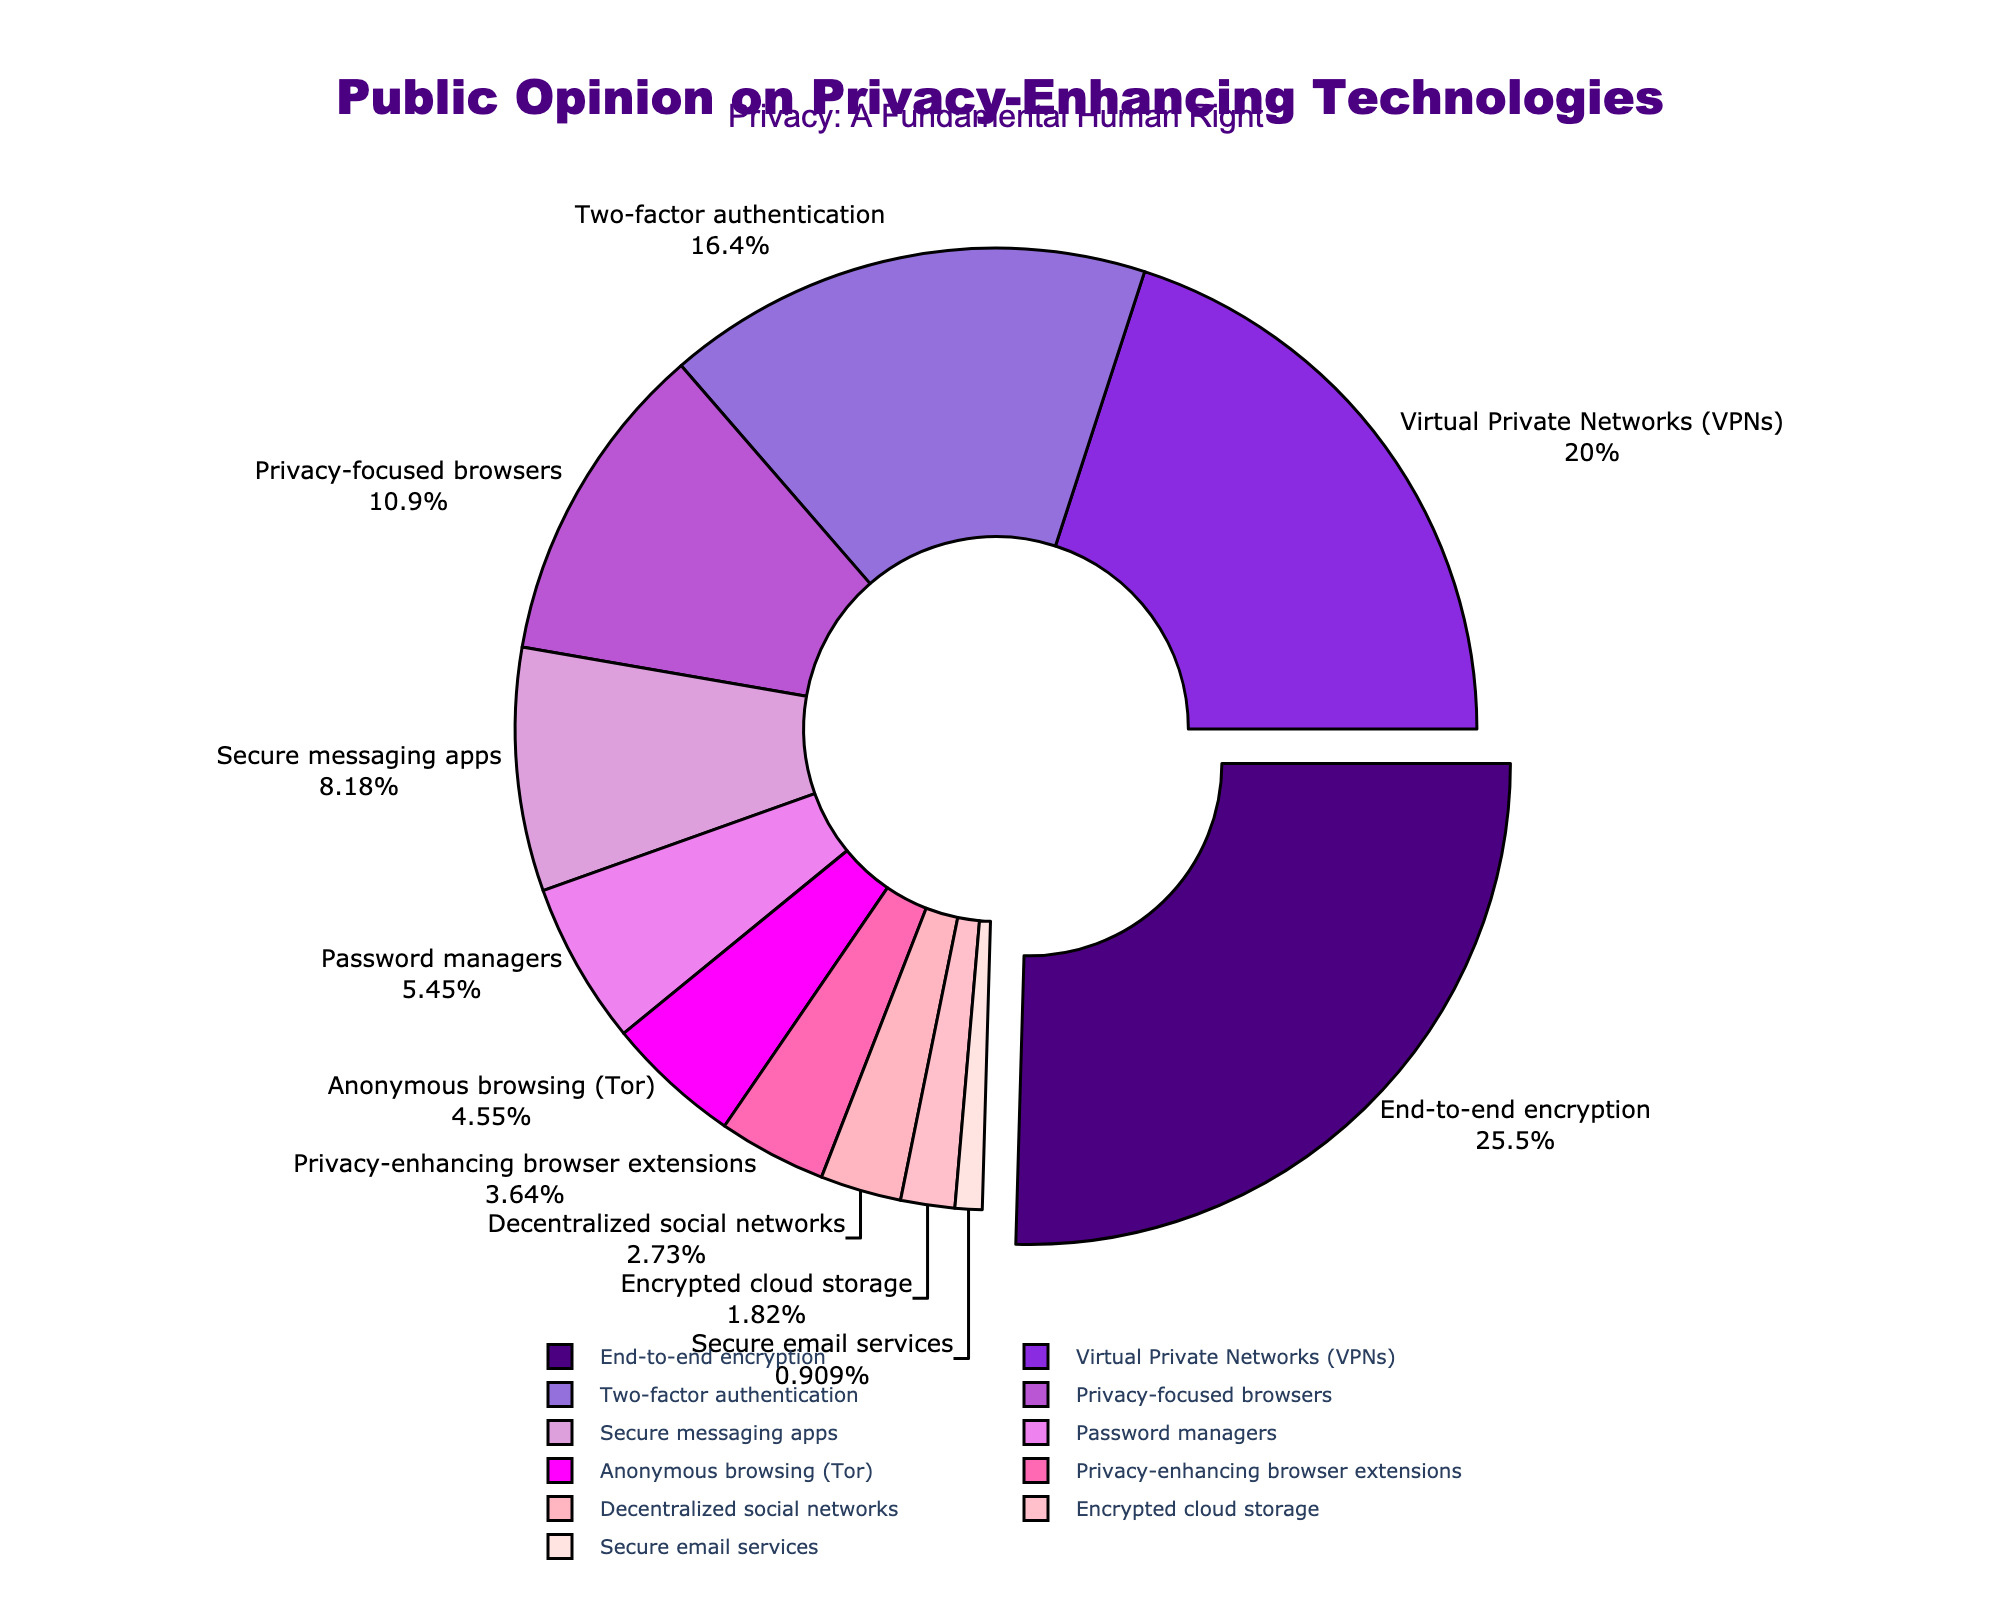what percentage of people prefer Privacy-focused browsers over Secure messaging apps? The figure shows that 12% of people prefer Privacy-focused browsers while 9% prefer Secure messaging apps. To calculate the percentage difference, subtract 9% from 12%, which results in 3%.
Answer: 3% Which privacy-enhancing technology is preferred by the largest share of people? Observing the pie chart, "End-to-end encryption" segment is the largest, indicating it's preferred by 28% of people, making it the most preferred technology.
Answer: End-to-end encryption What is the combined percentage of people who prefer technologies for password protection, i.e., Two-factor authentication and Password managers? To find the combined percentage, add the percentage of people who prefer Two-factor authentication (18%) and Password managers (6%). The sum is 18% + 6% = 24%.
Answer: 24% Are there more people who prefer VPNs or End-to-end encryption? According to the pie chart, 22% of people prefer VPNs while 28% prefer End-to-end encryption. Comparing these values, more people prefer End-to-end encryption.
Answer: End-to-end encryption What is the percentage difference between the least and the most preferred privacy-enhancing technologies? The least preferred technology is Secure email services (1%) and the most preferred is End-to-end encryption (28%). The percentage difference between them is 28% - 1% = 27%.
Answer: 27% What fraction of participants prefer technologies related to secure communication (considering Secure messaging apps, Two-factor authentication, and Secure email services)? Adding the percentages of Secure messaging apps (9%), Two-factor authentication (18%), and Secure email services (1%), we get 9% + 18% + 1% = 28%. This means 28% of participants prefer secure communication technologies.
Answer: 28% What is the cumulative percentage of people who favor technologies rated below Password managers? The technologies rated below Password managers (6%) include Anonymous browsing (Tor) (5%), Privacy-enhancing browser extensions (4%), Decentralized social networks (3%), Encrypted cloud storage (2%), and Secure email services (1%). Adding these, 5% + 4% + 3% + 2% + 1% = 15%.
Answer: 15% Which segment, indicated by a color closest to pink, corresponds to which technology? A segment colored closest to pink in the pie chart corresponds to Privacy-enhancing browser extensions (4%).
Answer: Privacy-enhancing browser extensions Considering the technologies listed, what is the average percentage preference? To compute the average preference, sum up all the given percentages and divide by the total number of technologies. (28% + 22% + 18% + 12% + 9% + 6% + 5% + 4% + 3% + 2% + 1% = 110%). The number of technologies is 11. Therefore, the average is 110% / 11 = 10%.
Answer: 10% Is the combined preference for Privacy-focused browsers and Secure messaging apps larger or smaller than the preference for VPNs? The combined preference for Privacy-focused browsers (12%) and Secure messaging apps (9%) is 12% + 9% = 21%. The preference for VPNs alone is 22%. 21% is smaller than 22%.
Answer: Smaller 